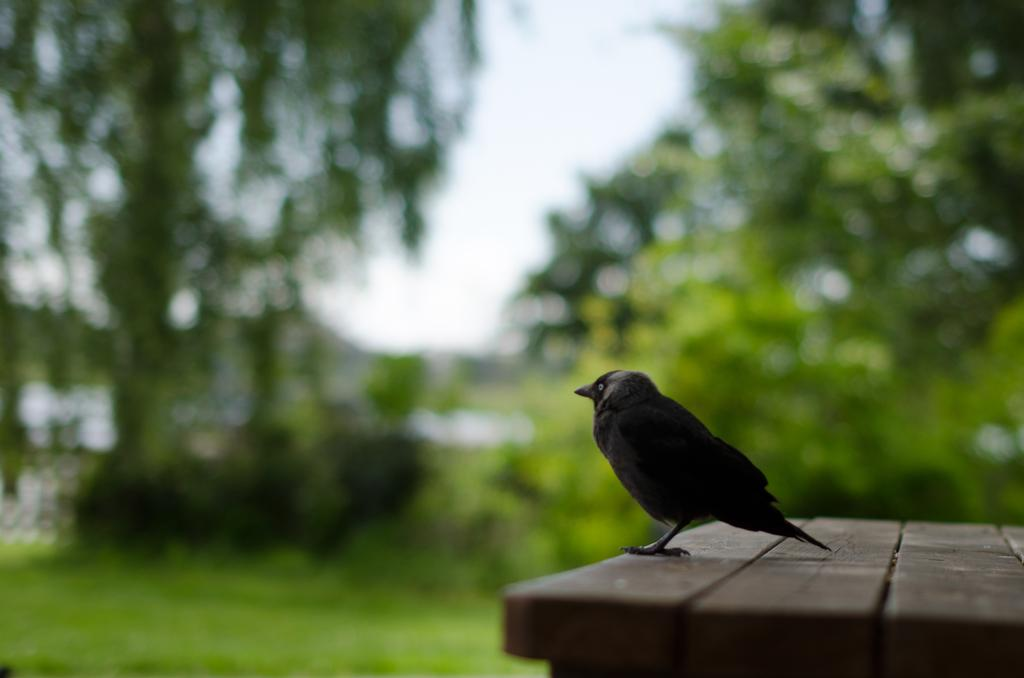What type of animal can be seen in the image? There is a bird in the image. Where is the bird located? The bird is on a wooden surface. What can be seen in the background of the image? There are plants, trees, and grassland visible in the background of the image. What is visible at the top of the image? The sky is visible at the top of the image. What type of cheese is being used to make a sandwich in the image? There is no cheese or sandwich present in the image; it features a bird on a wooden surface with a background of plants, trees, grassland, and the sky. 